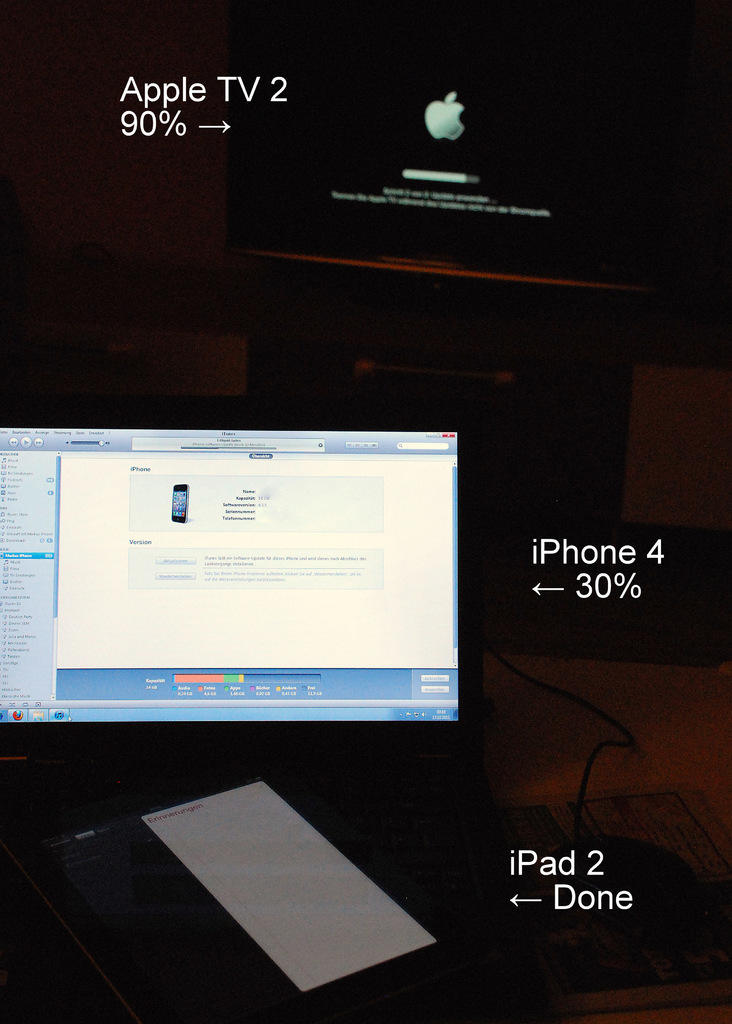Can you tell which Apple device model is shown and what is specifically being displayed on their screens? The devices shown include an iPhone 4, indicating about 30% progress on a task, an iPad 2 with a status showing 'Done', and an Apple TV 2 which is currently displaying a software update in progress. What can you infer about the user's interaction with these devices? The user seems to be managing updates or synchronization across multiple devices simultaneously, perhaps to ensure all devices are running the latest software or are in sync for media or data sharing purposes. 